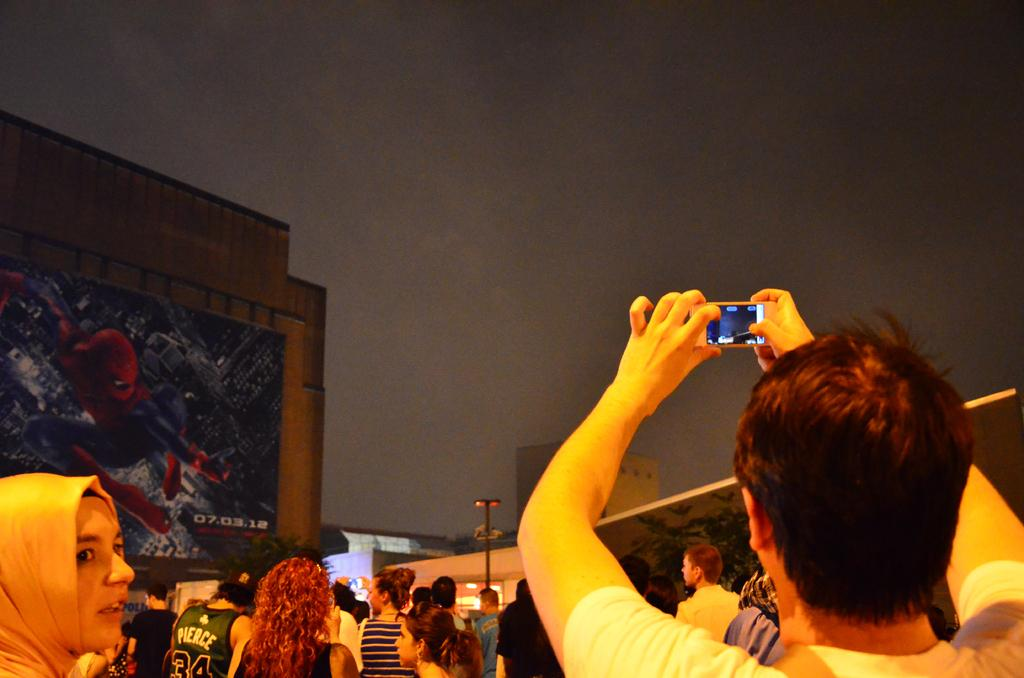How many people are in the image? There are many persons in the image. What are the people in the image doing? The persons are watching the sky. Can you identify any person holding a specific object in the image? Yes, there is a person holding a mobile phone. What is the person with the mobile phone doing? The person with the mobile phone is taking a video. What can be seen on the left side of the image? There is a poster of Spider-Man on the left side of the image. What type of substance is being sold at the market in the image? There is no market present in the image, so it is not possible to determine what type of substance might be sold there. 